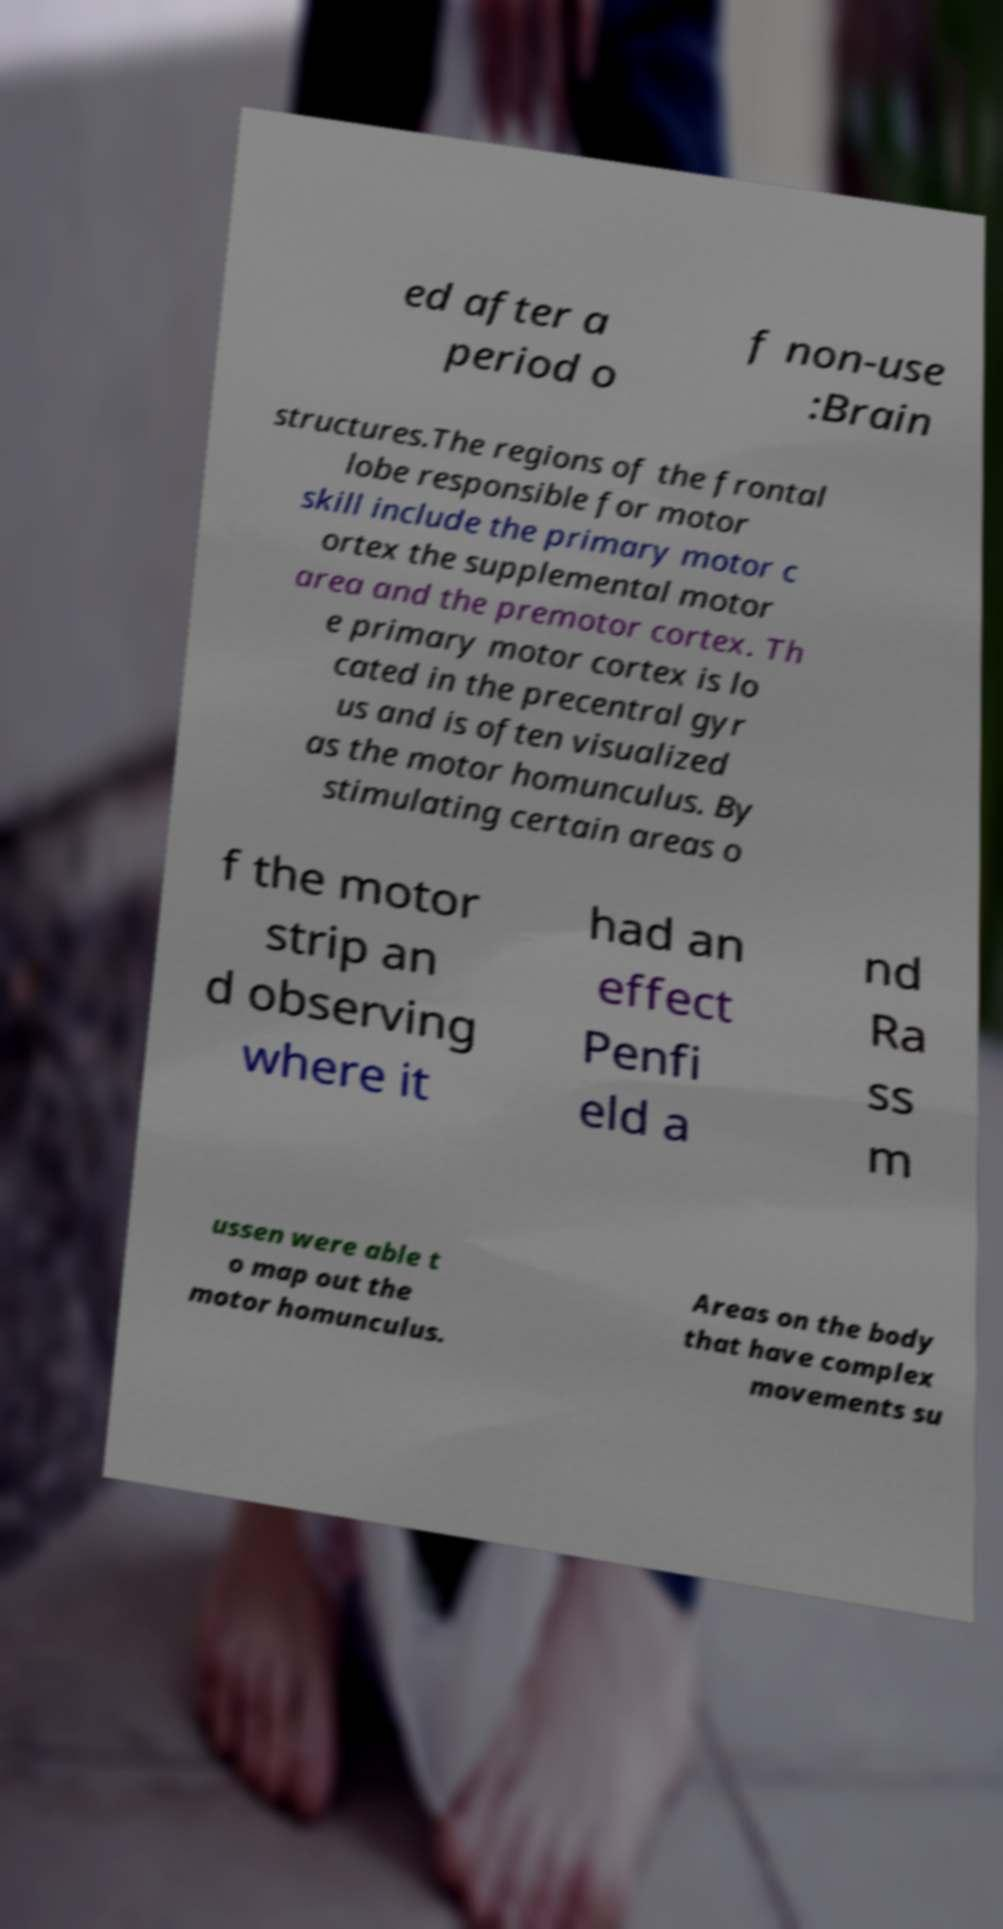Please identify and transcribe the text found in this image. ed after a period o f non-use :Brain structures.The regions of the frontal lobe responsible for motor skill include the primary motor c ortex the supplemental motor area and the premotor cortex. Th e primary motor cortex is lo cated in the precentral gyr us and is often visualized as the motor homunculus. By stimulating certain areas o f the motor strip an d observing where it had an effect Penfi eld a nd Ra ss m ussen were able t o map out the motor homunculus. Areas on the body that have complex movements su 